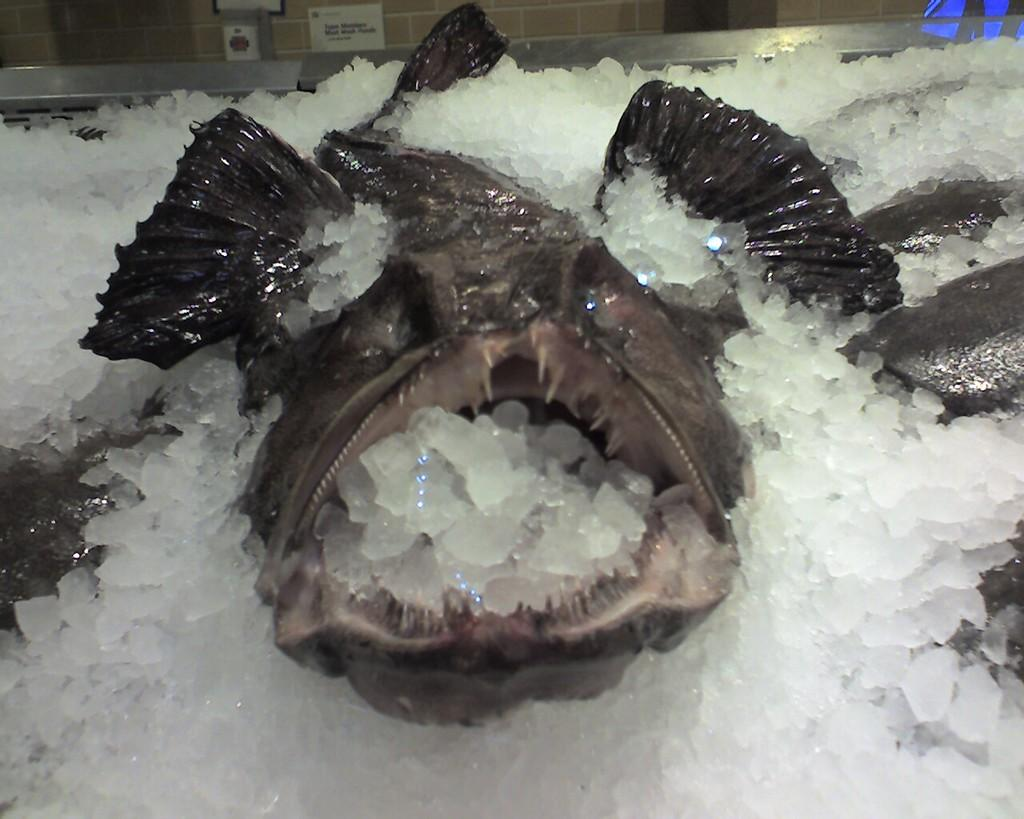What type of animals can be seen in the image? There are fish in the image. How are the fish being displayed or stored? The fish are in ice. What can be seen in the background of the image? There is a wall visible in the background of the image. What is on the wall in the background? There are posters on the wall in the background. What type of brass instrument is being played in the image? There is no brass instrument present in the image; it features fish in ice with posters on the wall in the background. 